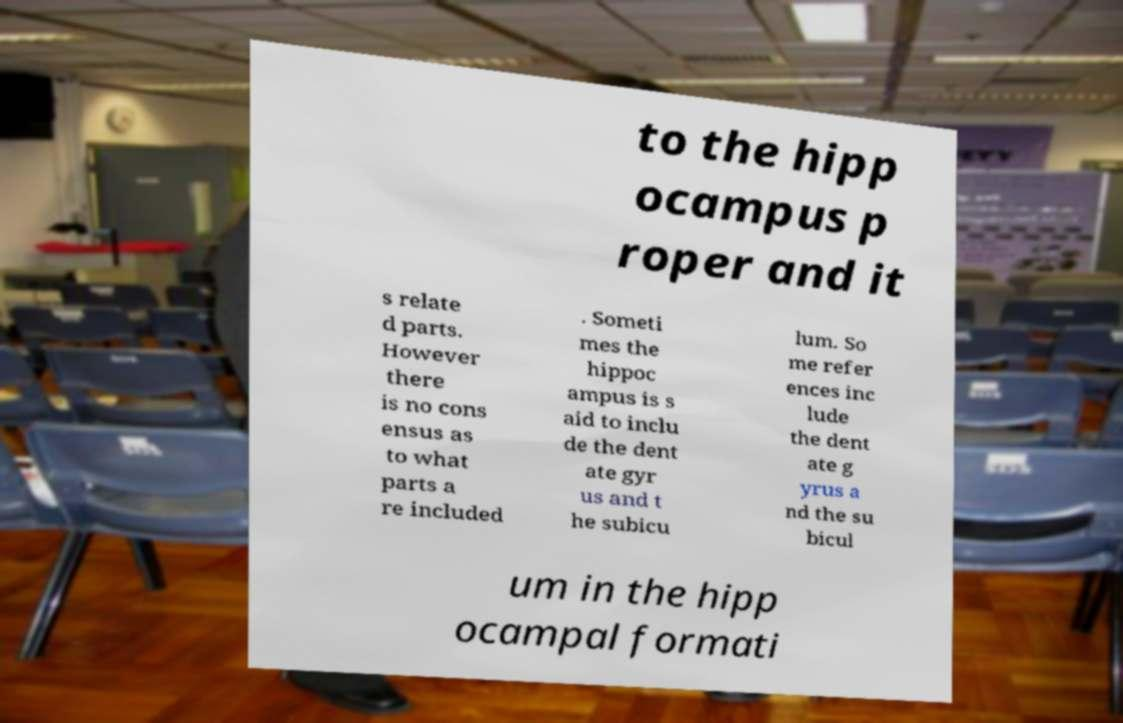Can you accurately transcribe the text from the provided image for me? to the hipp ocampus p roper and it s relate d parts. However there is no cons ensus as to what parts a re included . Someti mes the hippoc ampus is s aid to inclu de the dent ate gyr us and t he subicu lum. So me refer ences inc lude the dent ate g yrus a nd the su bicul um in the hipp ocampal formati 